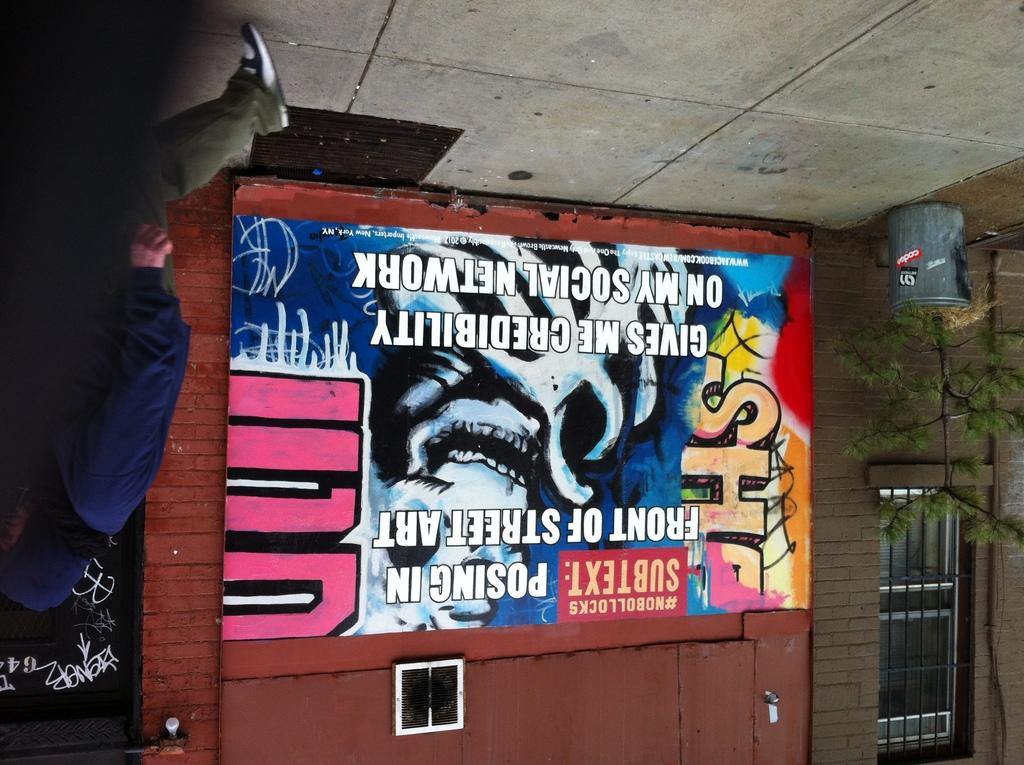What can be seen on the left side of the image? There is a person standing on the left side of the image. What is visible in the background of the image? There is a building and a trash bin in the background of the image. Reasoning: Let' Let's think step by step in order to produce the conversation. We start by identifying the main subject on the left side of the image, which is the person standing there. Then, we describe the background of the image, mentioning both the building and the trash bin. We avoid yes/no questions and ensure that the language is simple and clear. Absurd Question/Answer: What type of songs can be heard coming from the patch in the image? There is no patch or songs present in the image. 